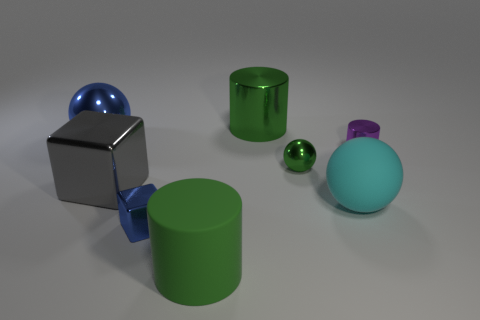What is the color of the large object that is both behind the large gray metal block and right of the big block?
Provide a short and direct response. Green. What is the color of the large shiny cylinder?
Ensure brevity in your answer.  Green. What material is the tiny cube that is the same color as the large metallic sphere?
Offer a very short reply. Metal. Is there a purple metallic thing of the same shape as the large cyan thing?
Give a very brief answer. No. There is a blue thing in front of the blue metal ball; how big is it?
Keep it short and to the point. Small. There is a cyan ball that is the same size as the gray shiny block; what is it made of?
Provide a succinct answer. Rubber. Are there more blue shiny spheres than metallic cubes?
Your answer should be very brief. No. What size is the metallic cylinder to the right of the small green object behind the tiny metallic cube?
Your answer should be very brief. Small. The blue object that is the same size as the green rubber cylinder is what shape?
Your answer should be compact. Sphere. The tiny thing to the left of the green cylinder to the right of the green cylinder that is in front of the tiny metallic cylinder is what shape?
Your answer should be very brief. Cube. 